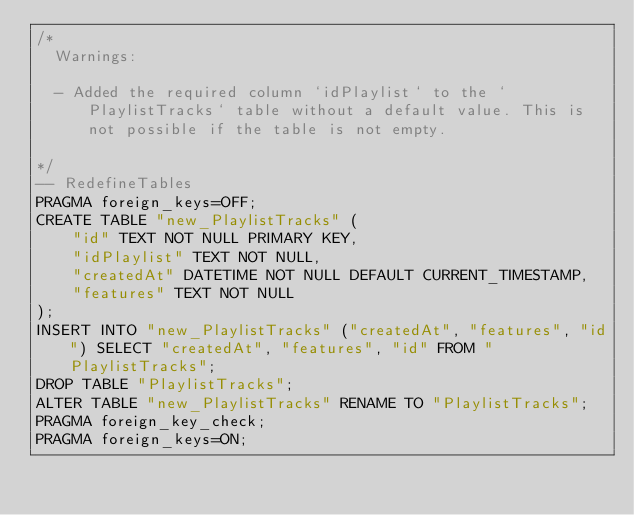Convert code to text. <code><loc_0><loc_0><loc_500><loc_500><_SQL_>/*
  Warnings:

  - Added the required column `idPlaylist` to the `PlaylistTracks` table without a default value. This is not possible if the table is not empty.

*/
-- RedefineTables
PRAGMA foreign_keys=OFF;
CREATE TABLE "new_PlaylistTracks" (
    "id" TEXT NOT NULL PRIMARY KEY,
    "idPlaylist" TEXT NOT NULL,
    "createdAt" DATETIME NOT NULL DEFAULT CURRENT_TIMESTAMP,
    "features" TEXT NOT NULL
);
INSERT INTO "new_PlaylistTracks" ("createdAt", "features", "id") SELECT "createdAt", "features", "id" FROM "PlaylistTracks";
DROP TABLE "PlaylistTracks";
ALTER TABLE "new_PlaylistTracks" RENAME TO "PlaylistTracks";
PRAGMA foreign_key_check;
PRAGMA foreign_keys=ON;
</code> 